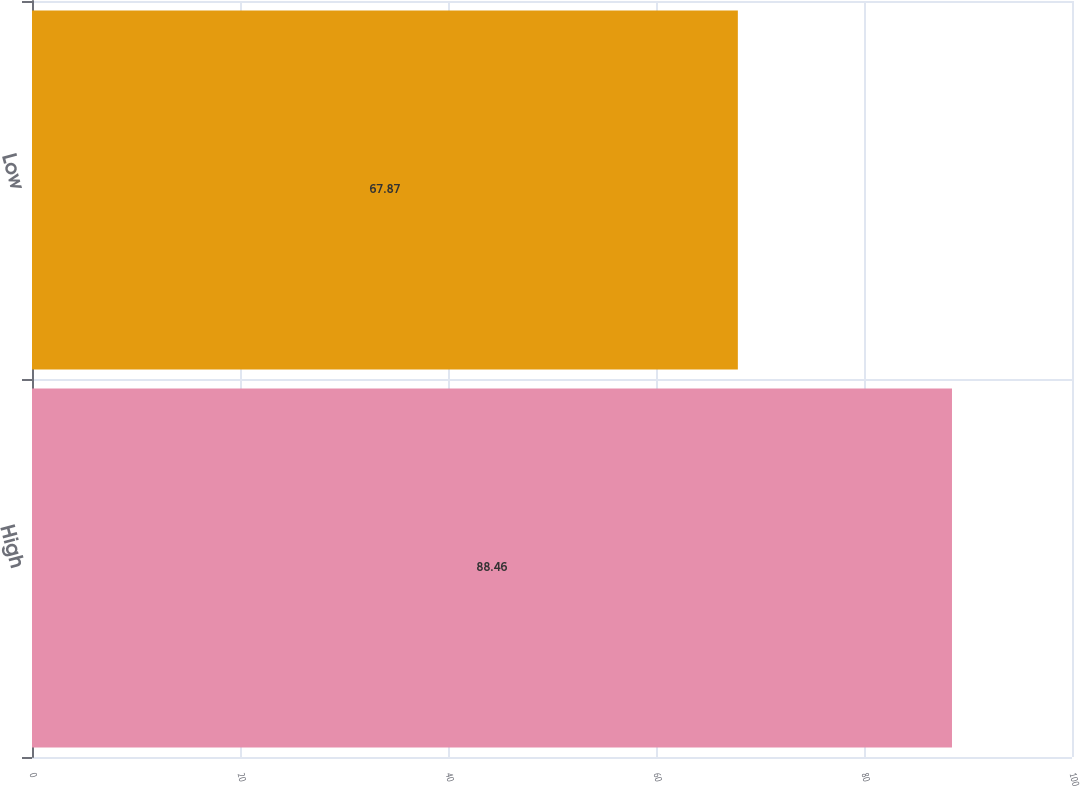Convert chart. <chart><loc_0><loc_0><loc_500><loc_500><bar_chart><fcel>High<fcel>Low<nl><fcel>88.46<fcel>67.87<nl></chart> 